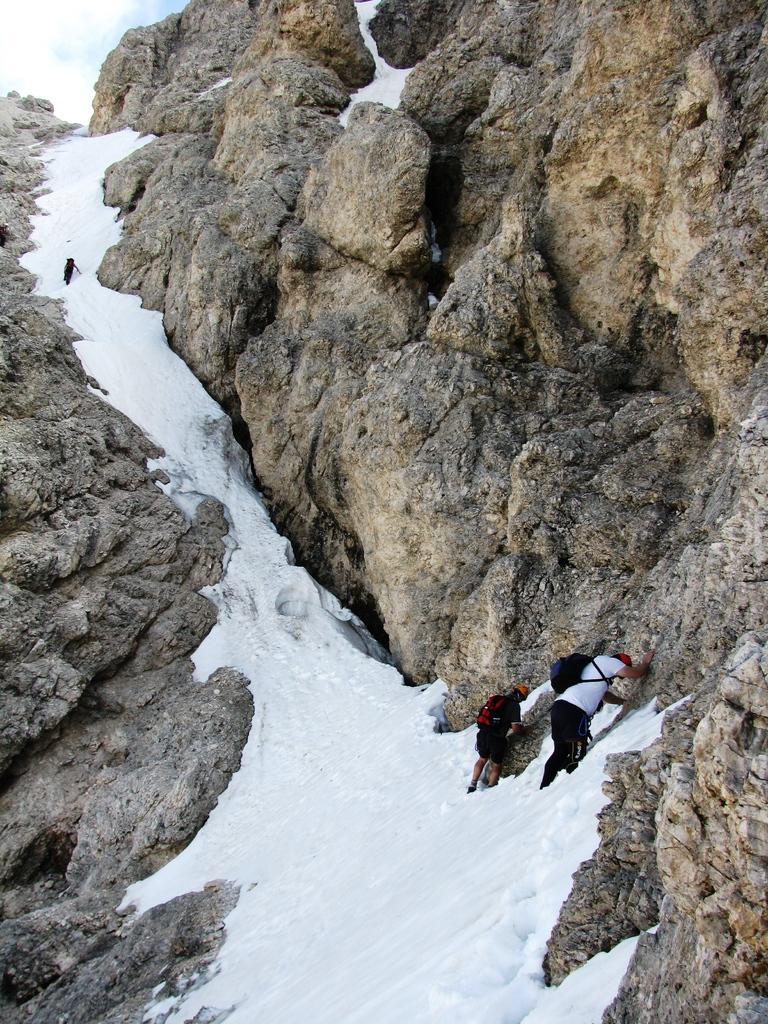Can you describe this image briefly? This is the picture of a hill. In this image there are three persons climbing the hill. At the top there is sky and there are clouds. At the bottom there is snow. 